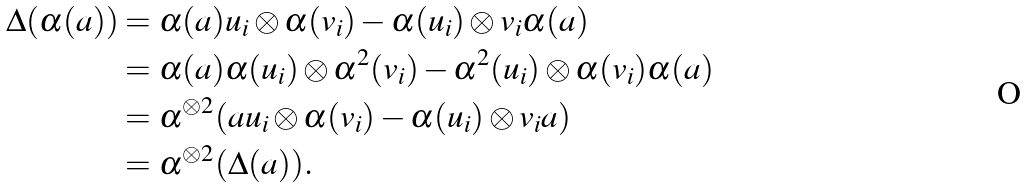<formula> <loc_0><loc_0><loc_500><loc_500>\Delta ( \alpha ( a ) ) & = \alpha ( a ) u _ { i } \otimes \alpha ( v _ { i } ) - \alpha ( u _ { i } ) \otimes v _ { i } \alpha ( a ) \\ & = \alpha ( a ) \alpha ( u _ { i } ) \otimes \alpha ^ { 2 } ( v _ { i } ) - \alpha ^ { 2 } ( u _ { i } ) \otimes \alpha ( v _ { i } ) \alpha ( a ) \\ & = \alpha ^ { \otimes 2 } ( a u _ { i } \otimes \alpha ( v _ { i } ) - \alpha ( u _ { i } ) \otimes v _ { i } a ) \\ & = \alpha ^ { \otimes 2 } ( \Delta ( a ) ) .</formula> 